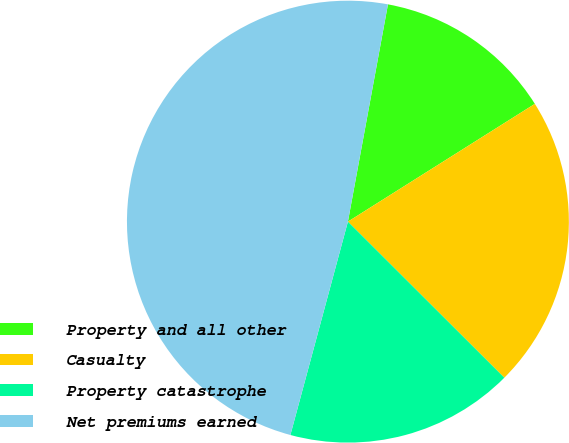<chart> <loc_0><loc_0><loc_500><loc_500><pie_chart><fcel>Property and all other<fcel>Casualty<fcel>Property catastrophe<fcel>Net premiums earned<nl><fcel>13.15%<fcel>21.43%<fcel>16.71%<fcel>48.71%<nl></chart> 